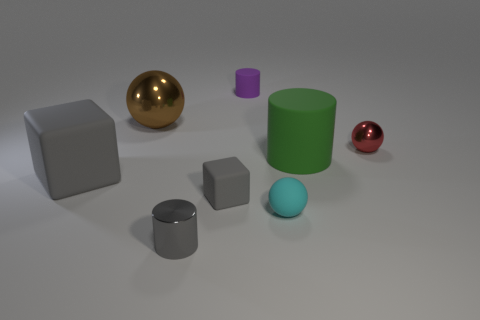There is a rubber thing that is to the left of the purple thing and on the right side of the large gray cube; what is its color?
Provide a succinct answer. Gray. Are the gray block in front of the large gray rubber block and the gray thing in front of the small gray matte block made of the same material?
Make the answer very short. No. Do the sphere right of the green cylinder and the large brown ball have the same size?
Give a very brief answer. No. There is a rubber ball; is its color the same as the tiny shiny thing right of the small gray metallic thing?
Your answer should be compact. No. There is a small thing that is the same color as the metallic cylinder; what shape is it?
Ensure brevity in your answer.  Cube. The large green rubber thing is what shape?
Your response must be concise. Cylinder. Does the large cube have the same color as the big sphere?
Offer a very short reply. No. What number of things are small rubber things that are in front of the small rubber block or gray metallic cylinders?
Make the answer very short. 2. There is a green cylinder that is the same material as the purple cylinder; what size is it?
Your answer should be compact. Large. Are there more gray rubber objects behind the small purple cylinder than large gray blocks?
Offer a very short reply. No. 